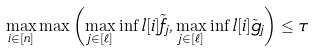Convert formula to latex. <formula><loc_0><loc_0><loc_500><loc_500>\max _ { i \in [ n ] } \max \left ( \max _ { j \in [ \ell ] } \inf l [ i ] { \tilde { f } _ { j } } , \max _ { j \in [ \ell ] } \inf l [ i ] { \tilde { g } _ { j } } \right ) \leq \tau</formula> 